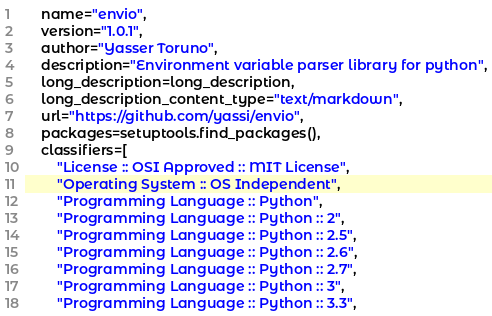<code> <loc_0><loc_0><loc_500><loc_500><_Python_>    name="envio",
    version="1.0.1",
    author="Yasser Toruno",
    description="Environment variable parser library for python",
    long_description=long_description,
    long_description_content_type="text/markdown",
    url="https://github.com/yassi/envio",
    packages=setuptools.find_packages(),
    classifiers=[
        "License :: OSI Approved :: MIT License",
        "Operating System :: OS Independent",
        "Programming Language :: Python",
        "Programming Language :: Python :: 2",
        "Programming Language :: Python :: 2.5",
        "Programming Language :: Python :: 2.6",
        "Programming Language :: Python :: 2.7",
        "Programming Language :: Python :: 3",
        "Programming Language :: Python :: 3.3",</code> 